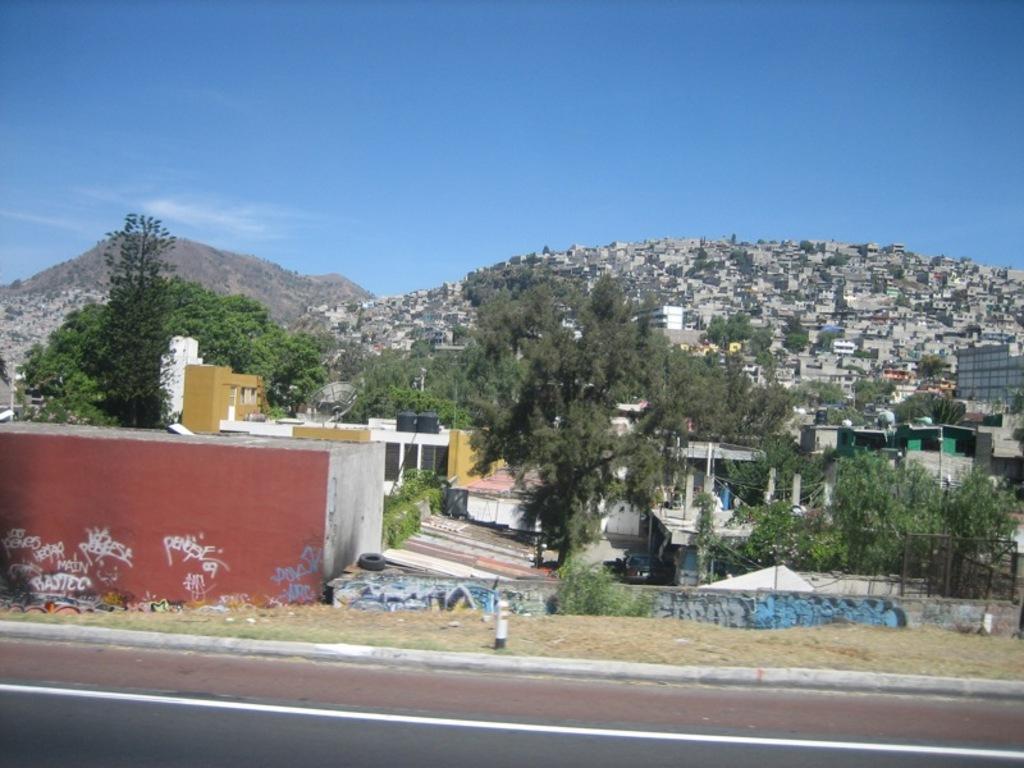In one or two sentences, can you explain what this image depicts? In this image we can see sky with clouds, hills, trees, buildings, sheds and road. 